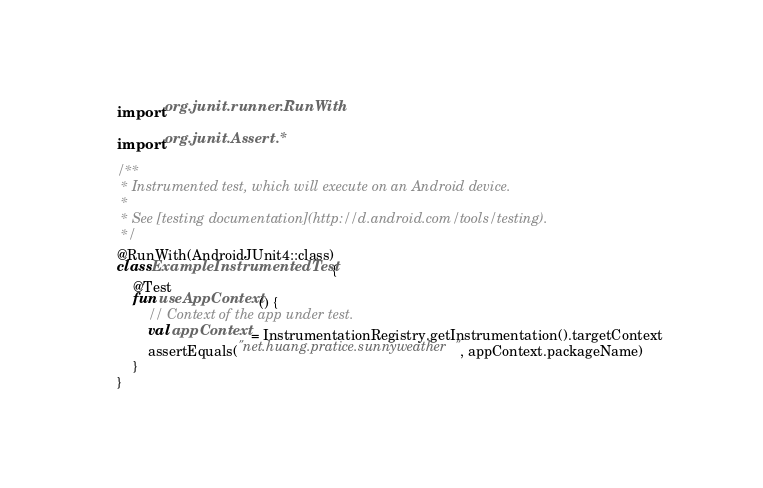Convert code to text. <code><loc_0><loc_0><loc_500><loc_500><_Kotlin_>import org.junit.runner.RunWith

import org.junit.Assert.*

/**
 * Instrumented test, which will execute on an Android device.
 *
 * See [testing documentation](http://d.android.com/tools/testing).
 */
@RunWith(AndroidJUnit4::class)
class ExampleInstrumentedTest {
    @Test
    fun useAppContext() {
        // Context of the app under test.
        val appContext = InstrumentationRegistry.getInstrumentation().targetContext
        assertEquals("net.huang.pratice.sunnyweather", appContext.packageName)
    }
}</code> 